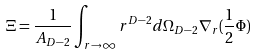<formula> <loc_0><loc_0><loc_500><loc_500>\Xi = \frac { 1 } { A _ { D - 2 } } \int _ { r \to \infty } r ^ { D - 2 } d \Omega _ { D - 2 } \nabla _ { r } ( { \frac { 1 } { 2 } } \Phi )</formula> 